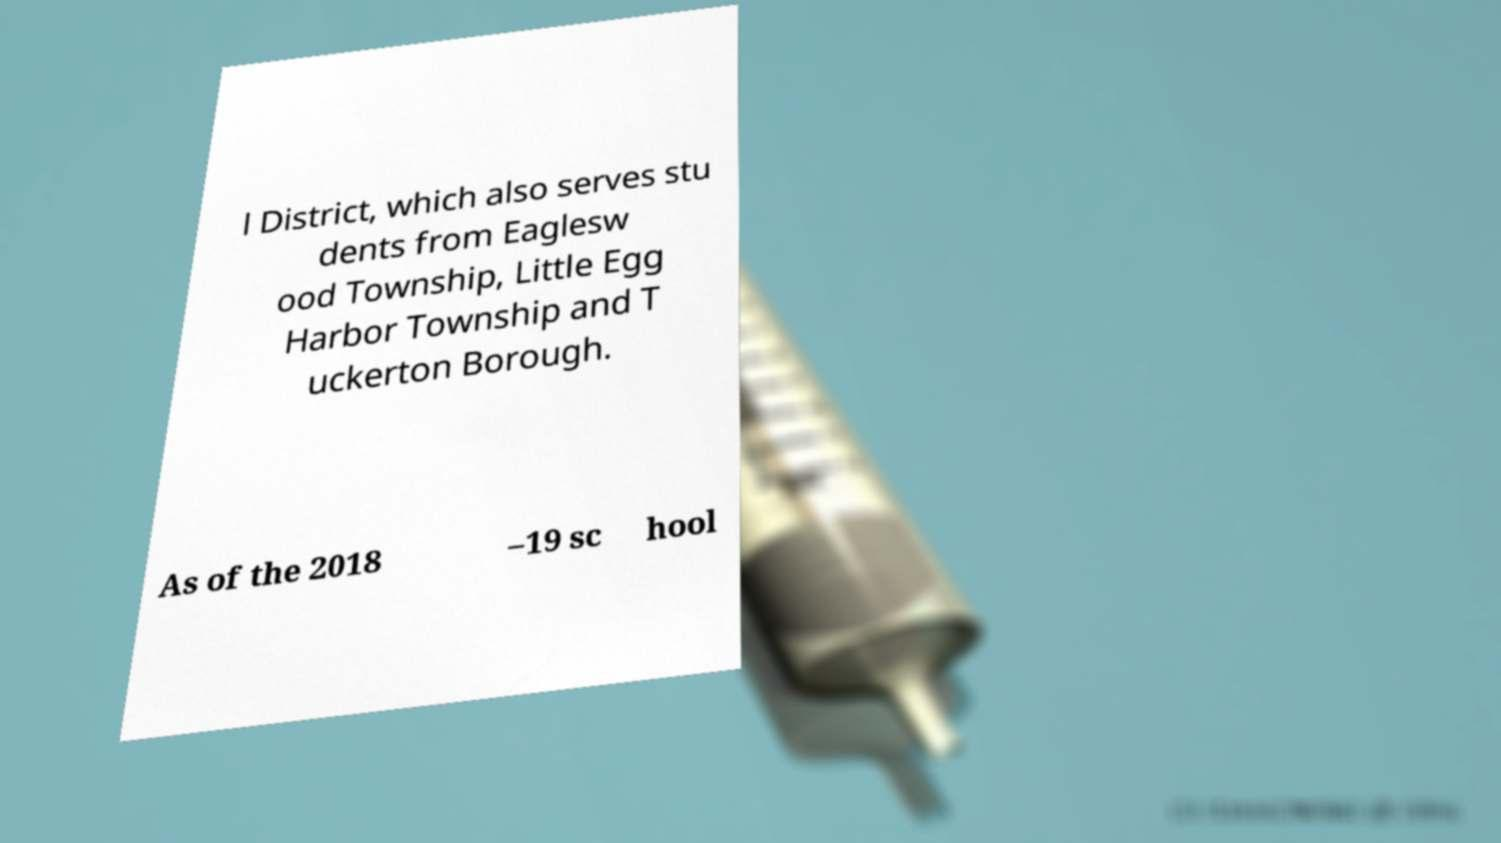Can you accurately transcribe the text from the provided image for me? l District, which also serves stu dents from Eaglesw ood Township, Little Egg Harbor Township and T uckerton Borough. As of the 2018 –19 sc hool 